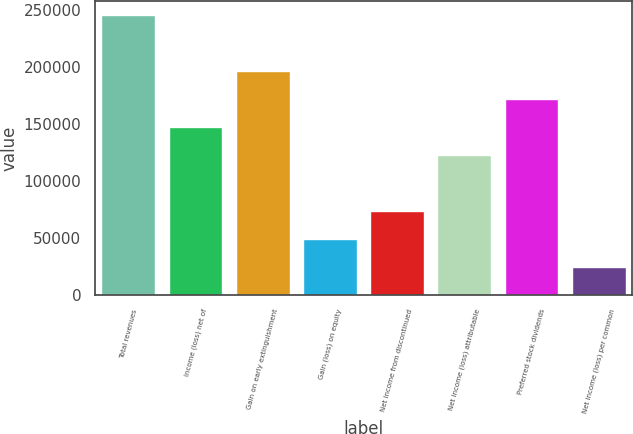Convert chart. <chart><loc_0><loc_0><loc_500><loc_500><bar_chart><fcel>Total revenues<fcel>Income (loss) net of<fcel>Gain on early extinguishment<fcel>Gain (loss) on equity<fcel>Net income from discontinued<fcel>Net income (loss) attributable<fcel>Preferred stock dividends<fcel>Net income (loss) per common<nl><fcel>245769<fcel>147461<fcel>196615<fcel>49153.8<fcel>73730.7<fcel>122885<fcel>172038<fcel>24576.9<nl></chart> 